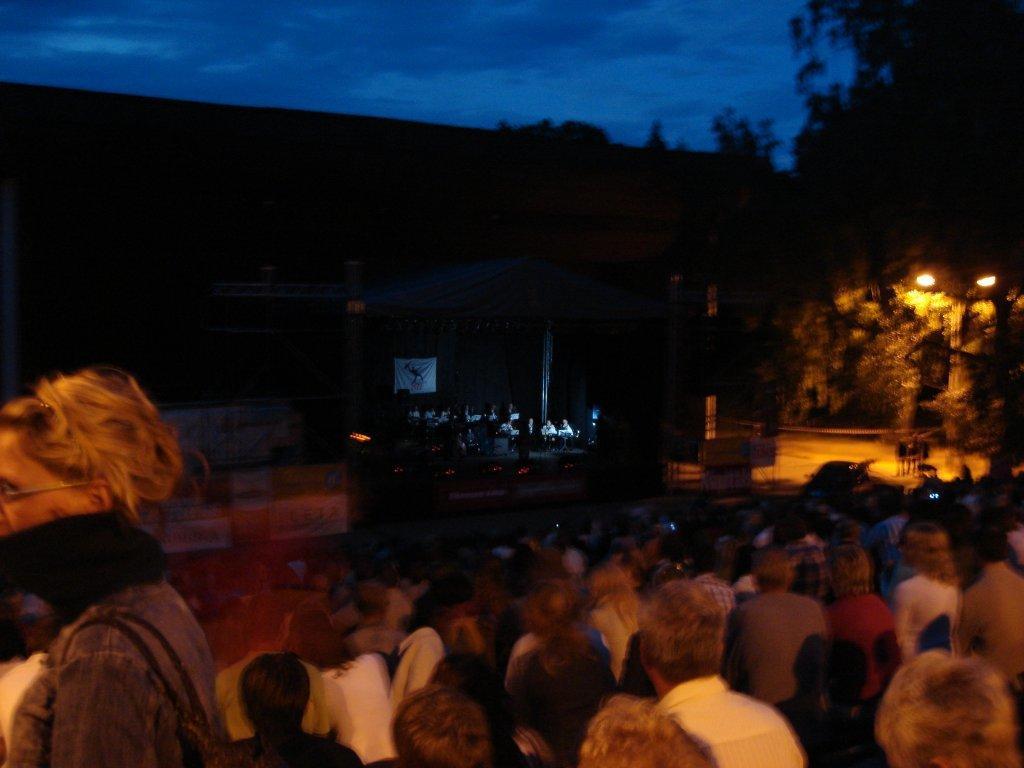In one or two sentences, can you explain what this image depicts? In this image we can see a group of persons. On the right side, we can see few trees and a pole with lights. The background of the image is dark. At the top we can see the sky. 